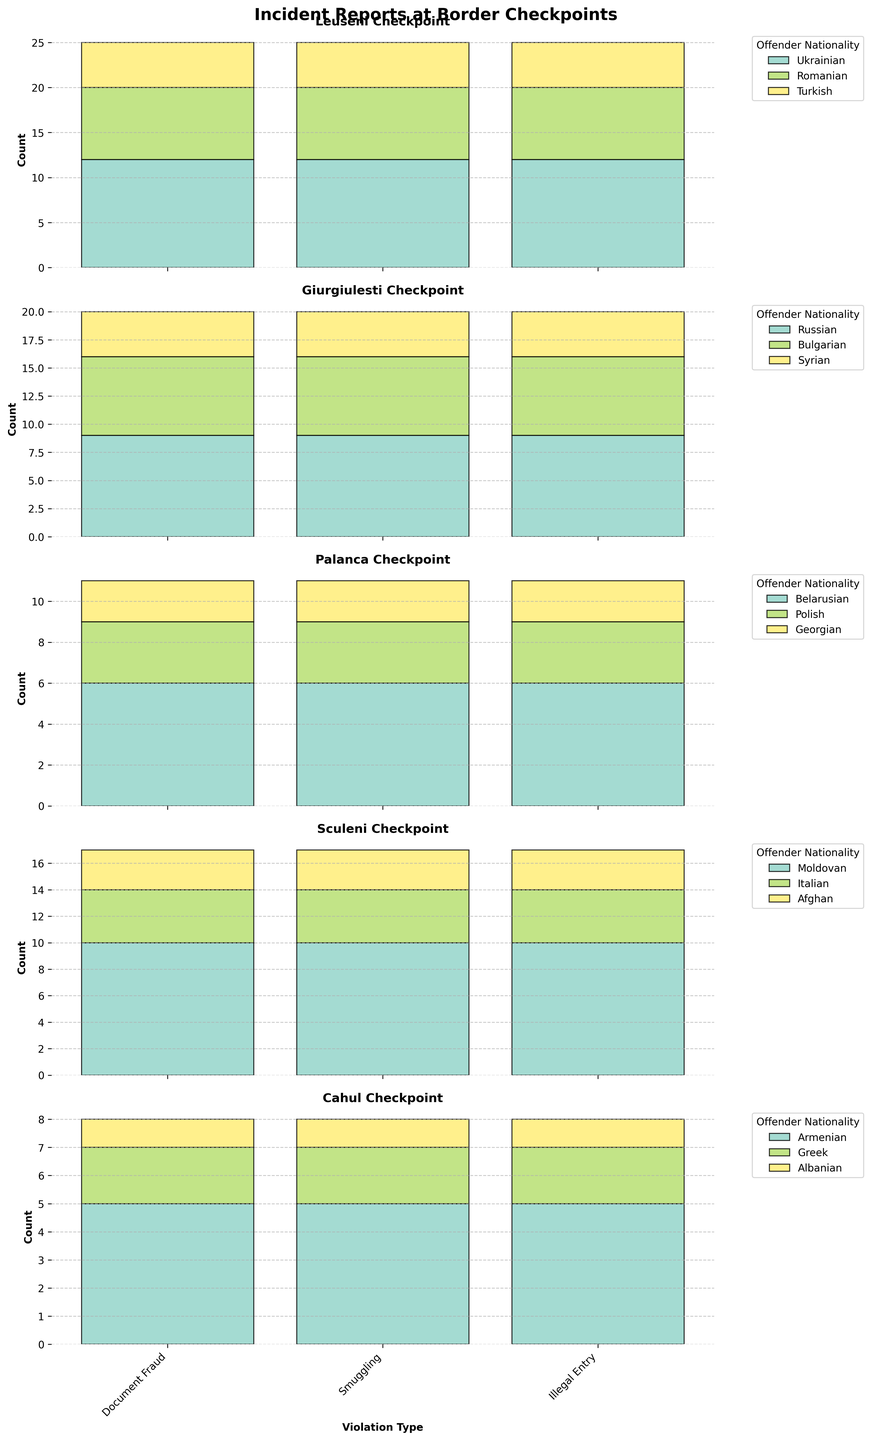How many incidents of Document Fraud were reported at the Leuseni checkpoint? Look at the subplot for Leuseni checkpoint and find the bar corresponding to Document Fraud. The count is indicated by the height of the bar.
Answer: 12 Which checkpoint reported the highest number of Smuggling incidents? Compare the heights of the Smuggling bars across all subplots. The longest bar indicates the highest count.
Answer: Leuseni How many incidents of Illegal Entry were reported at the Giurgiulesti checkpoint? Find the Illegal Entry bar in the Giurgiulesti checkpoint subplot and read its value.
Answer: 4 What is the sum of Document Fraud incidents across all checkpoints? Add the count of Document Fraud incidents from each checkpoint: Leuseni (12), Giurgiulesti (9), Palanca (6), Sculeni (10), Cahul (5).
Answer: 42 Which nationality offenders were reported the most frequently at the Sculeni checkpoint? Identify the nationality that appears most frequently in the legend of the Sculeni checkpoint subplot, summed across all violations.
Answer: Moldovan How do the Smuggling incidents at Cahul compare to those at Palanca? Look at the Smuggling bars for both Cahul and Palanca checkpoints, and compare their heights.
Answer: Higher at Palanca What violation type has the most incidents reported at the Palanca checkpoint? Observe the subplot for Palanca checkpoint and identify the tallest bar among all violation types.
Answer: Document Fraud Which checkpoint had the lowest total number of incidents reported? Sum the heights of all bars in each checkpoint subplot and compare the totals, identifying the lowest sum.
Answer: Cahul What is the total number of Illegal Entry incidents reported across all checkpoints? Add the counts of Illegal Entry incidents from each checkpoint: Leuseni (5), Giurgiulesti (4), Palanca (2), Sculeni (3), Cahul (1).
Answer: 15 